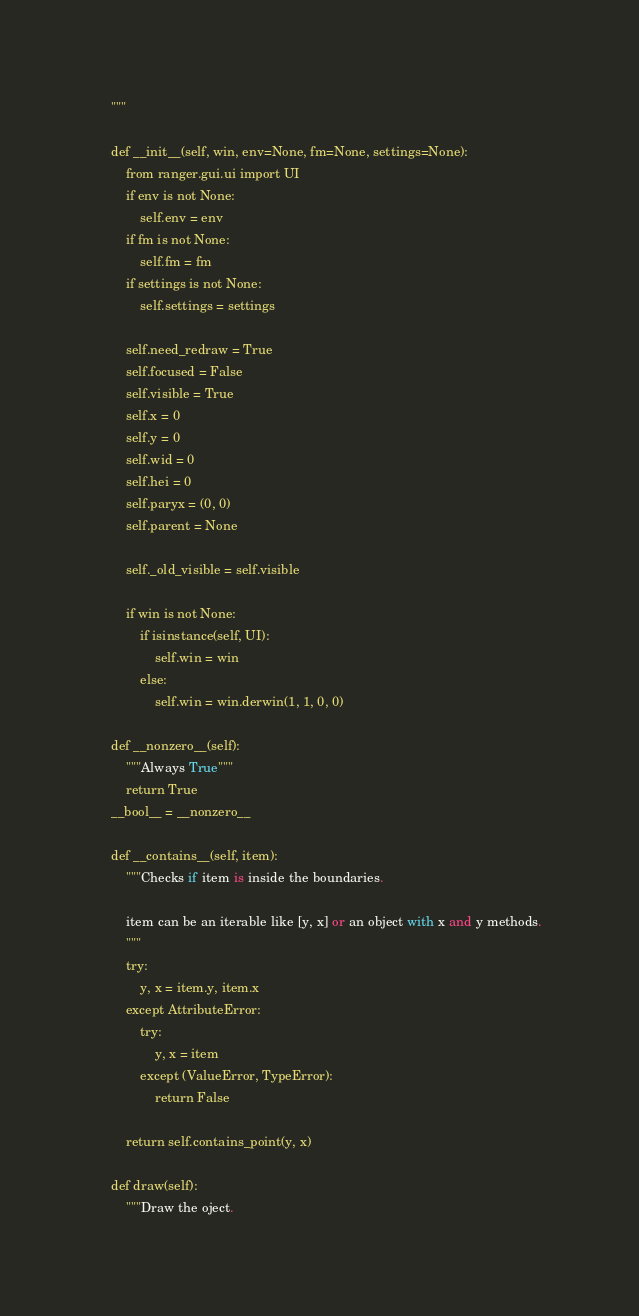Convert code to text. <code><loc_0><loc_0><loc_500><loc_500><_Python_>    """

    def __init__(self, win, env=None, fm=None, settings=None):
        from ranger.gui.ui import UI
        if env is not None:
            self.env = env
        if fm is not None:
            self.fm = fm
        if settings is not None:
            self.settings = settings

        self.need_redraw = True
        self.focused = False
        self.visible = True
        self.x = 0
        self.y = 0
        self.wid = 0
        self.hei = 0
        self.paryx = (0, 0)
        self.parent = None

        self._old_visible = self.visible

        if win is not None:
            if isinstance(self, UI):
                self.win = win
            else:
                self.win = win.derwin(1, 1, 0, 0)

    def __nonzero__(self):
        """Always True"""
        return True
    __bool__ = __nonzero__

    def __contains__(self, item):
        """Checks if item is inside the boundaries.

        item can be an iterable like [y, x] or an object with x and y methods.
        """
        try:
            y, x = item.y, item.x
        except AttributeError:
            try:
                y, x = item
            except (ValueError, TypeError):
                return False

        return self.contains_point(y, x)

    def draw(self):
        """Draw the oject.
</code> 